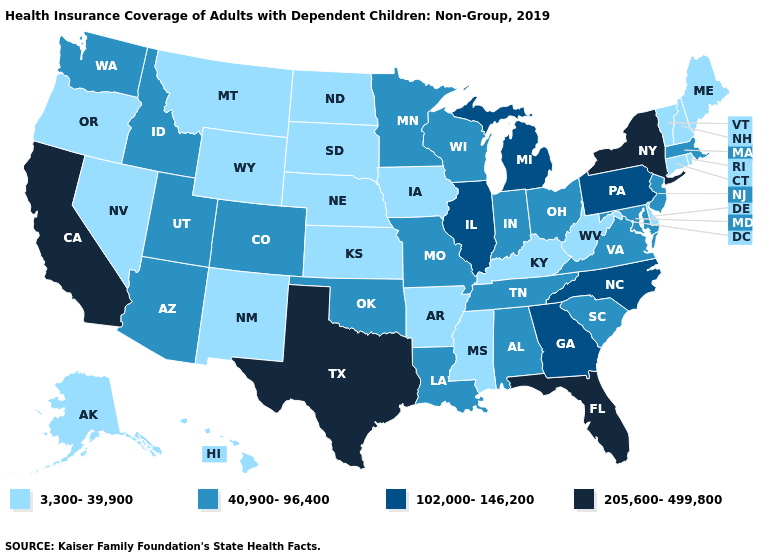What is the lowest value in states that border Maine?
Be succinct. 3,300-39,900. Name the states that have a value in the range 102,000-146,200?
Quick response, please. Georgia, Illinois, Michigan, North Carolina, Pennsylvania. What is the highest value in the USA?
Short answer required. 205,600-499,800. Which states have the lowest value in the USA?
Write a very short answer. Alaska, Arkansas, Connecticut, Delaware, Hawaii, Iowa, Kansas, Kentucky, Maine, Mississippi, Montana, Nebraska, Nevada, New Hampshire, New Mexico, North Dakota, Oregon, Rhode Island, South Dakota, Vermont, West Virginia, Wyoming. What is the lowest value in the MidWest?
Be succinct. 3,300-39,900. Name the states that have a value in the range 40,900-96,400?
Give a very brief answer. Alabama, Arizona, Colorado, Idaho, Indiana, Louisiana, Maryland, Massachusetts, Minnesota, Missouri, New Jersey, Ohio, Oklahoma, South Carolina, Tennessee, Utah, Virginia, Washington, Wisconsin. Name the states that have a value in the range 205,600-499,800?
Be succinct. California, Florida, New York, Texas. Does Oregon have the same value as Mississippi?
Write a very short answer. Yes. Does Florida have the lowest value in the USA?
Keep it brief. No. What is the value of Kentucky?
Concise answer only. 3,300-39,900. What is the value of Kansas?
Quick response, please. 3,300-39,900. Does Idaho have the lowest value in the West?
Concise answer only. No. Name the states that have a value in the range 3,300-39,900?
Answer briefly. Alaska, Arkansas, Connecticut, Delaware, Hawaii, Iowa, Kansas, Kentucky, Maine, Mississippi, Montana, Nebraska, Nevada, New Hampshire, New Mexico, North Dakota, Oregon, Rhode Island, South Dakota, Vermont, West Virginia, Wyoming. Does Oklahoma have a lower value than Wisconsin?
Quick response, please. No. What is the value of New Jersey?
Keep it brief. 40,900-96,400. 